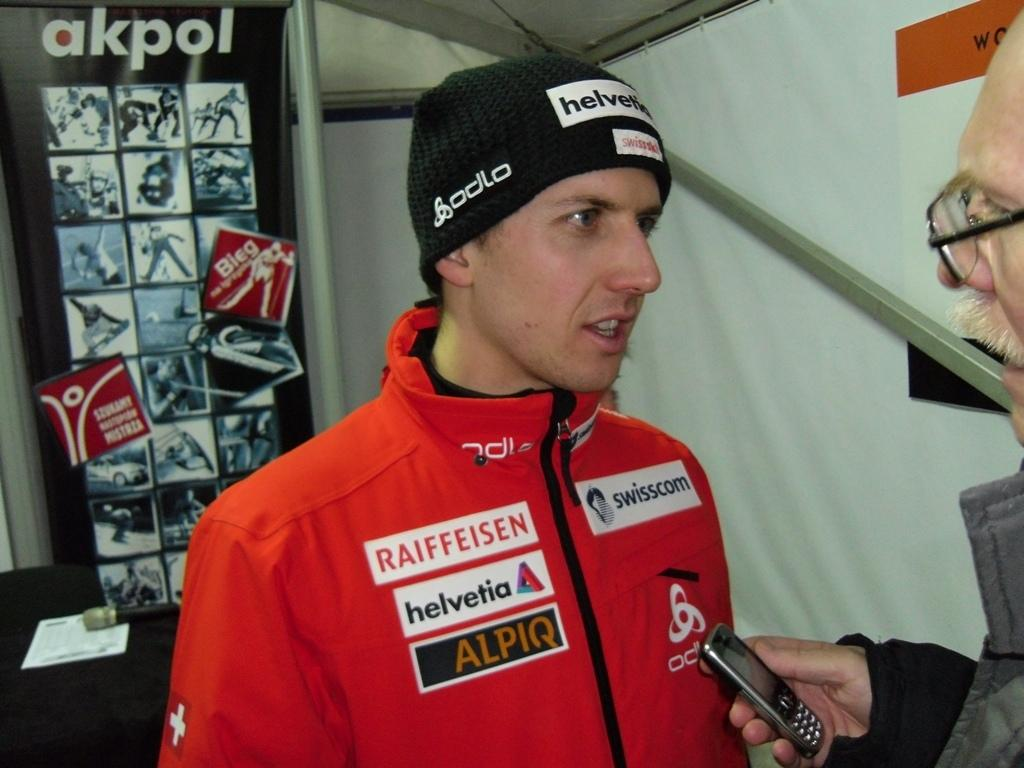<image>
Provide a brief description of the given image. a jacket on a person that says helvetia on it 